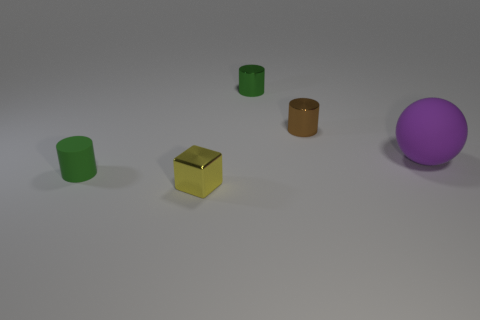How many green cylinders must be subtracted to get 1 green cylinders? 1 Add 3 metallic cylinders. How many objects exist? 8 Subtract all cylinders. How many objects are left? 2 Add 2 tiny yellow shiny things. How many tiny yellow shiny things are left? 3 Add 3 rubber spheres. How many rubber spheres exist? 4 Subtract 0 cyan spheres. How many objects are left? 5 Subtract all yellow rubber things. Subtract all tiny green rubber cylinders. How many objects are left? 4 